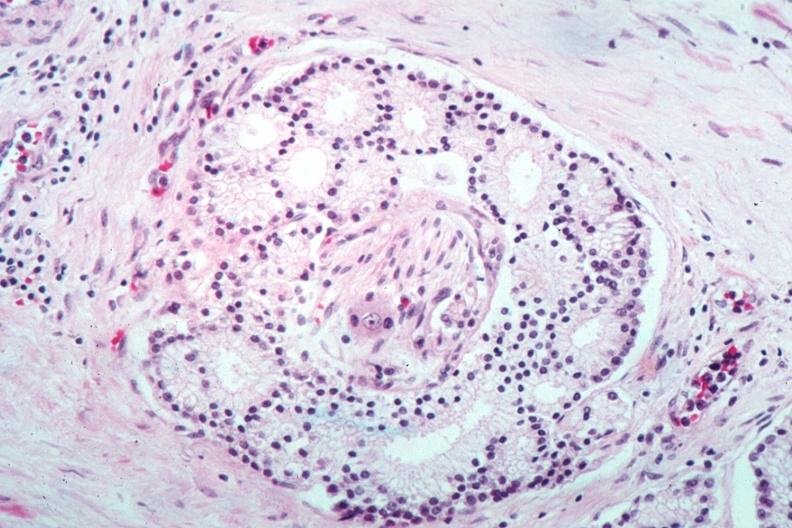what is present?
Answer the question using a single word or phrase. Prostate 